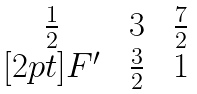Convert formula to latex. <formula><loc_0><loc_0><loc_500><loc_500>\begin{matrix} \frac { 1 } { 2 } \, & \, 3 \, & \, \frac { 7 } { 2 } \\ [ 2 p t ] F ^ { \prime } \, & \, \frac { 3 } { 2 } \, & \, 1 \end{matrix}</formula> 